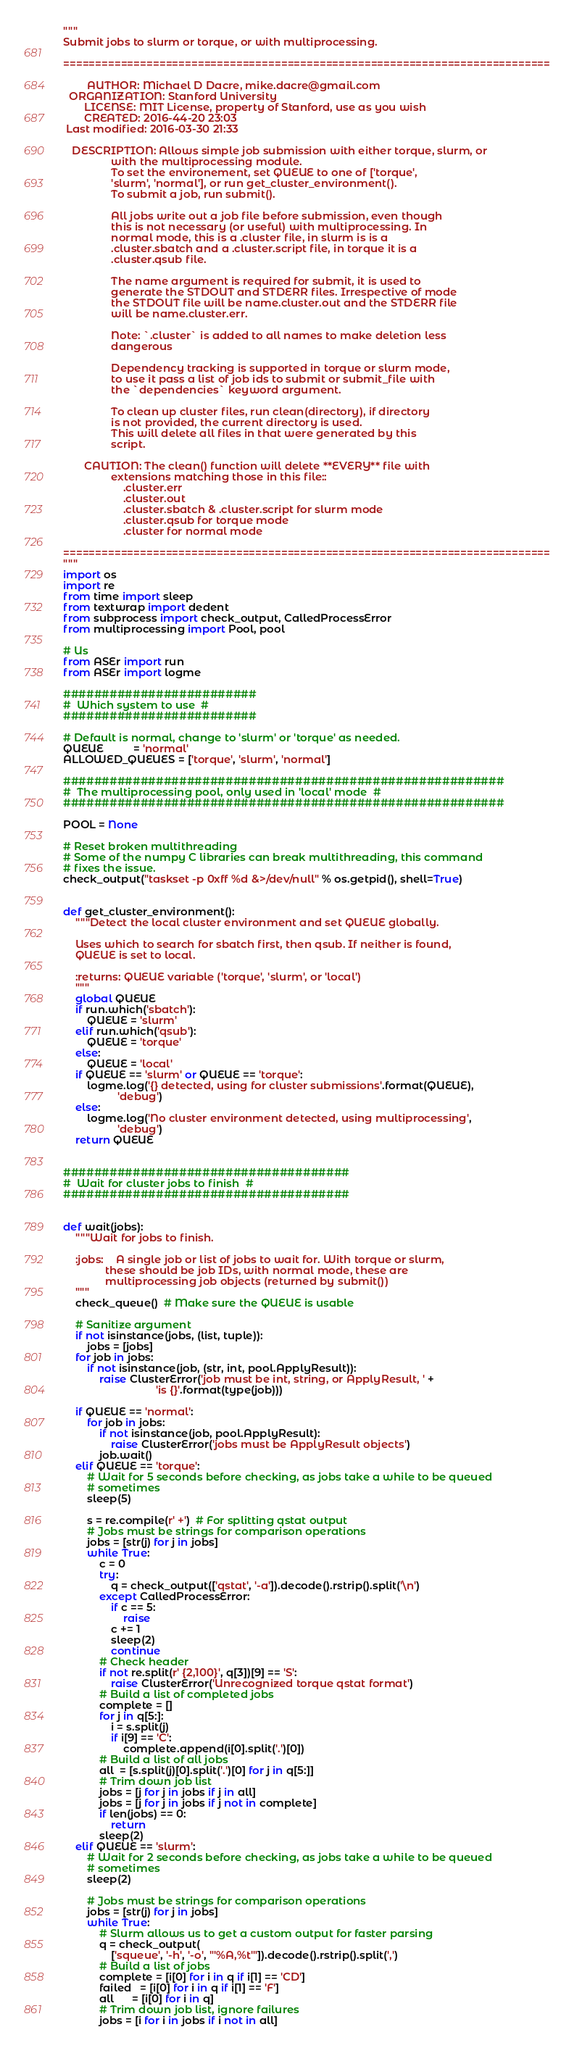Convert code to text. <code><loc_0><loc_0><loc_500><loc_500><_Python_>"""
Submit jobs to slurm or torque, or with multiprocessing.

============================================================================

        AUTHOR: Michael D Dacre, mike.dacre@gmail.com
  ORGANIZATION: Stanford University
       LICENSE: MIT License, property of Stanford, use as you wish
       CREATED: 2016-44-20 23:03
 Last modified: 2016-03-30 21:33

   DESCRIPTION: Allows simple job submission with either torque, slurm, or
                with the multiprocessing module.
                To set the environement, set QUEUE to one of ['torque',
                'slurm', 'normal'], or run get_cluster_environment().
                To submit a job, run submit().

                All jobs write out a job file before submission, even though
                this is not necessary (or useful) with multiprocessing. In
                normal mode, this is a .cluster file, in slurm is is a
                .cluster.sbatch and a .cluster.script file, in torque it is a
                .cluster.qsub file.

                The name argument is required for submit, it is used to
                generate the STDOUT and STDERR files. Irrespective of mode
                the STDOUT file will be name.cluster.out and the STDERR file
                will be name.cluster.err.

                Note: `.cluster` is added to all names to make deletion less
                dangerous

                Dependency tracking is supported in torque or slurm mode,
                to use it pass a list of job ids to submit or submit_file with
                the `dependencies` keyword argument.

                To clean up cluster files, run clean(directory), if directory
                is not provided, the current directory is used.
                This will delete all files in that were generated by this
                script.

       CAUTION: The clean() function will delete **EVERY** file with
                extensions matching those in this file::
                    .cluster.err
                    .cluster.out
                    .cluster.sbatch & .cluster.script for slurm mode
                    .cluster.qsub for torque mode
                    .cluster for normal mode

============================================================================
"""
import os
import re
from time import sleep
from textwrap import dedent
from subprocess import check_output, CalledProcessError
from multiprocessing import Pool, pool

# Us
from ASEr import run
from ASEr import logme

#########################
#  Which system to use  #
#########################

# Default is normal, change to 'slurm' or 'torque' as needed.
QUEUE          = 'normal'
ALLOWED_QUEUES = ['torque', 'slurm', 'normal']

#########################################################
#  The multiprocessing pool, only used in 'local' mode  #
#########################################################

POOL = None

# Reset broken multithreading
# Some of the numpy C libraries can break multithreading, this command
# fixes the issue.
check_output("taskset -p 0xff %d &>/dev/null" % os.getpid(), shell=True)


def get_cluster_environment():
    """Detect the local cluster environment and set QUEUE globally.

    Uses which to search for sbatch first, then qsub. If neither is found,
    QUEUE is set to local.

    :returns: QUEUE variable ('torque', 'slurm', or 'local')
    """
    global QUEUE
    if run.which('sbatch'):
        QUEUE = 'slurm'
    elif run.which('qsub'):
        QUEUE = 'torque'
    else:
        QUEUE = 'local'
    if QUEUE == 'slurm' or QUEUE == 'torque':
        logme.log('{} detected, using for cluster submissions'.format(QUEUE),
                  'debug')
    else:
        logme.log('No cluster environment detected, using multiprocessing',
                  'debug')
    return QUEUE


#####################################
#  Wait for cluster jobs to finish  #
#####################################


def wait(jobs):
    """Wait for jobs to finish.

    :jobs:    A single job or list of jobs to wait for. With torque or slurm,
              these should be job IDs, with normal mode, these are
              multiprocessing job objects (returned by submit())
    """
    check_queue()  # Make sure the QUEUE is usable

    # Sanitize argument
    if not isinstance(jobs, (list, tuple)):
        jobs = [jobs]
    for job in jobs:
        if not isinstance(job, (str, int, pool.ApplyResult)):
            raise ClusterError('job must be int, string, or ApplyResult, ' +
                               'is {}'.format(type(job)))

    if QUEUE == 'normal':
        for job in jobs:
            if not isinstance(job, pool.ApplyResult):
                raise ClusterError('jobs must be ApplyResult objects')
            job.wait()
    elif QUEUE == 'torque':
        # Wait for 5 seconds before checking, as jobs take a while to be queued
        # sometimes
        sleep(5)

        s = re.compile(r' +')  # For splitting qstat output
        # Jobs must be strings for comparison operations
        jobs = [str(j) for j in jobs]
        while True:
            c = 0
            try:
                q = check_output(['qstat', '-a']).decode().rstrip().split('\n')
            except CalledProcessError:
                if c == 5:
                    raise
                c += 1
                sleep(2)
                continue
            # Check header
            if not re.split(r' {2,100}', q[3])[9] == 'S':
                raise ClusterError('Unrecognized torque qstat format')
            # Build a list of completed jobs
            complete = []
            for j in q[5:]:
                i = s.split(j)
                if i[9] == 'C':
                    complete.append(i[0].split('.')[0])
            # Build a list of all jobs
            all  = [s.split(j)[0].split('.')[0] for j in q[5:]]
            # Trim down job list
            jobs = [j for j in jobs if j in all]
            jobs = [j for j in jobs if j not in complete]
            if len(jobs) == 0:
                return
            sleep(2)
    elif QUEUE == 'slurm':
        # Wait for 2 seconds before checking, as jobs take a while to be queued
        # sometimes
        sleep(2)

        # Jobs must be strings for comparison operations
        jobs = [str(j) for j in jobs]
        while True:
            # Slurm allows us to get a custom output for faster parsing
            q = check_output(
                ['squeue', '-h', '-o', "'%A,%t'"]).decode().rstrip().split(',')
            # Build a list of jobs
            complete = [i[0] for i in q if i[1] == 'CD']
            failed   = [i[0] for i in q if i[1] == 'F']
            all      = [i[0] for i in q]
            # Trim down job list, ignore failures
            jobs = [i for i in jobs if i not in all]</code> 